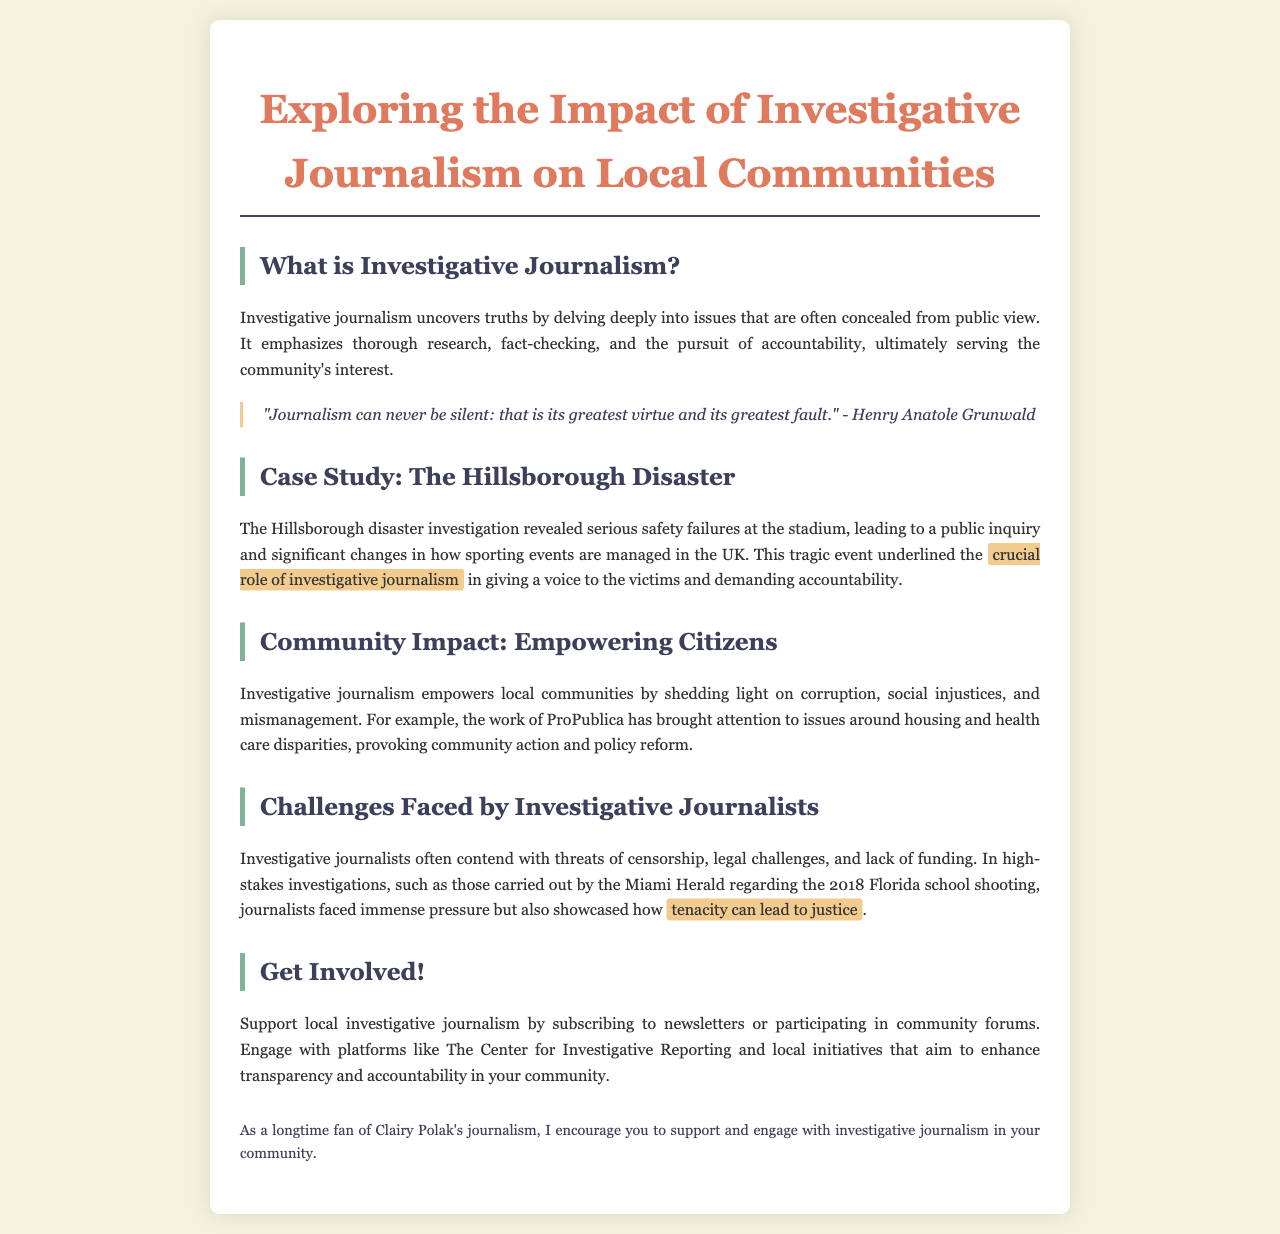What is investigative journalism? The definition provided in the document explains that investigative journalism uncovers truths by delving deeply into issues that are often concealed from public view.
Answer: Investigative journalism uncovers truths What was revealed by the Hillsborough disaster investigation? The document states that the investigation revealed serious safety failures at the stadium leading to changes in how sporting events are managed.
Answer: Serious safety failures What organization is mentioned as bringing attention to housing and health care disparities? The document references ProPublica as an organization that has brought attention to those issues.
Answer: ProPublica What challenges do investigative journalists face? The document lists threats of censorship, legal challenges, and lack of funding as challenges faced by investigative journalists.
Answer: Censorship What event did the Miami Herald investigate? The document mentions that the Miami Herald investigated the 2018 Florida school shooting.
Answer: 2018 Florida school shooting How does the document suggest supporting local investigative journalism? The document encourages support by subscribing to newsletters or participating in community forums.
Answer: Subscribing to newsletters What significant role does investigative journalism play in communities? The document highlights that investigative journalism empowers local communities by shedding light on corruption and social injustices.
Answer: Empowering local communities Who is quoted in the brochure about journalism? The brochure features a quote from Henry Anatole Grunwald regarding journalism.
Answer: Henry Anatole Grunwald 